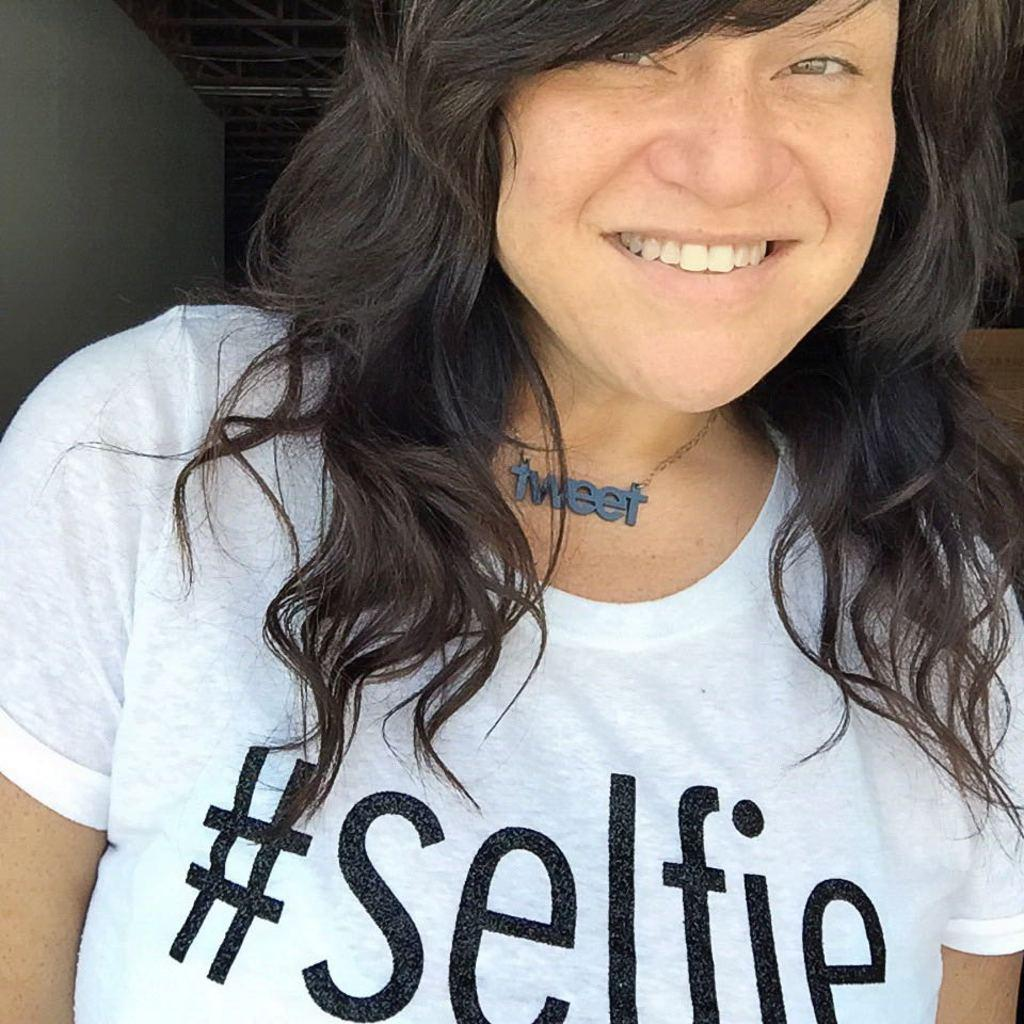Who is the main subject in the picture? There is a woman in the picture. What is the woman wearing on her upper body? The woman is wearing a t-shirt. What is written on the t-shirt? The t-shirt has a hashtag selfie written on it. What accessory is the woman wearing around her neck? The woman is wearing a locket. What is the woman's facial expression in the picture? The woman is smiling. Where is the woman standing in the picture? The woman is standing near a wall. What type of waves can be seen crashing against the shore in the image? There are no waves or shore visible in the image; it features a woman standing near a wall. What type of form does the woman's trousers have in the image? The provided facts do not mention the woman's trousers, so we cannot determine their form from the image. 